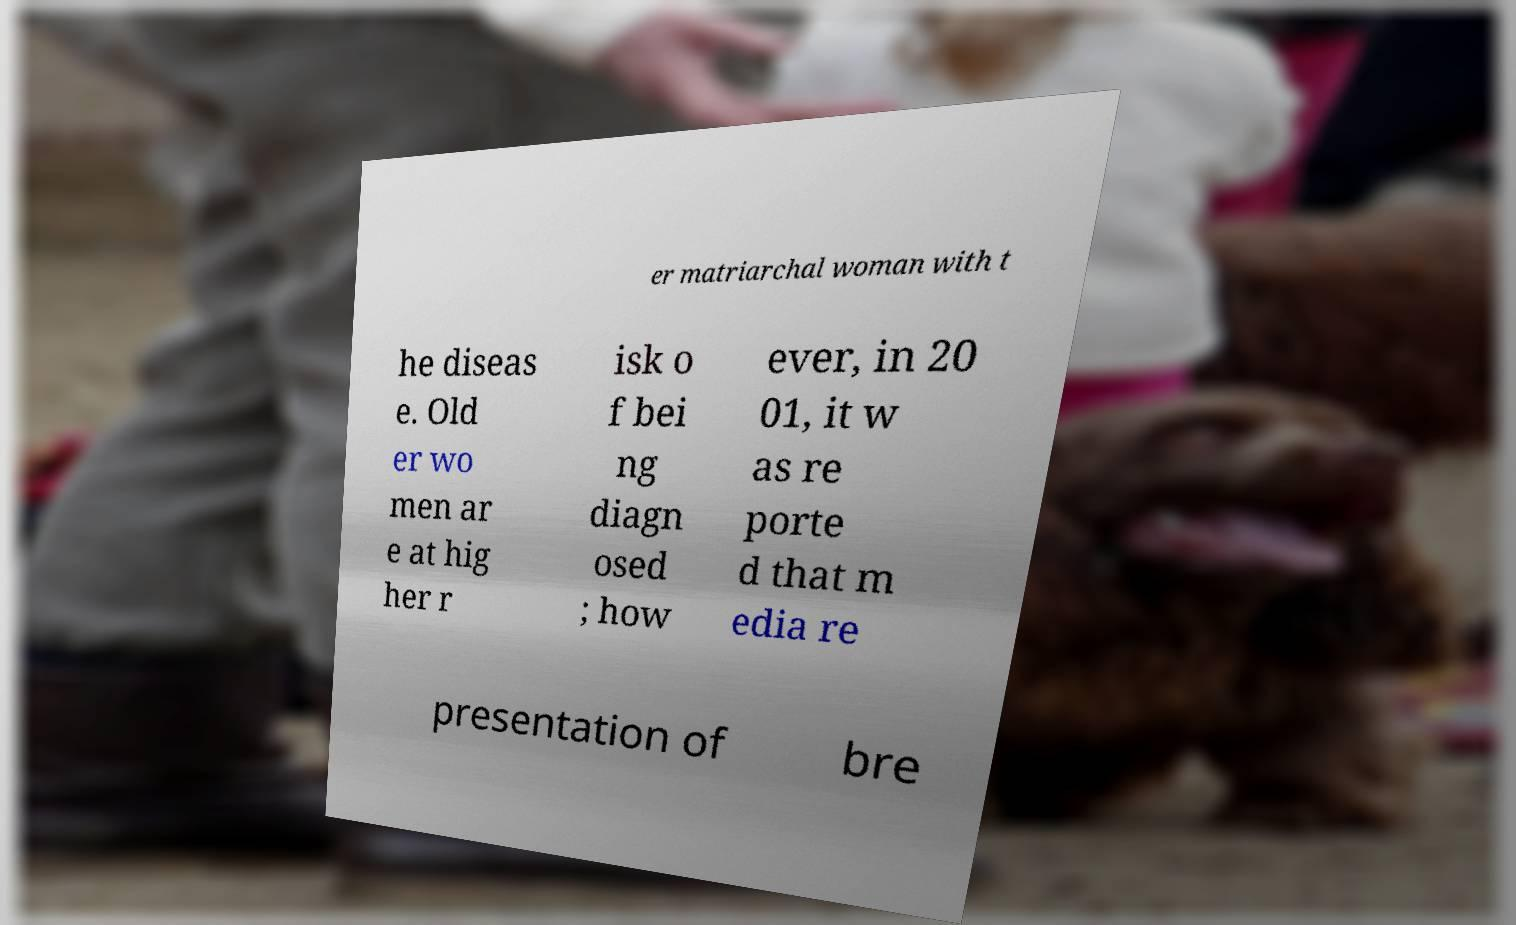Can you read and provide the text displayed in the image?This photo seems to have some interesting text. Can you extract and type it out for me? er matriarchal woman with t he diseas e. Old er wo men ar e at hig her r isk o f bei ng diagn osed ; how ever, in 20 01, it w as re porte d that m edia re presentation of bre 